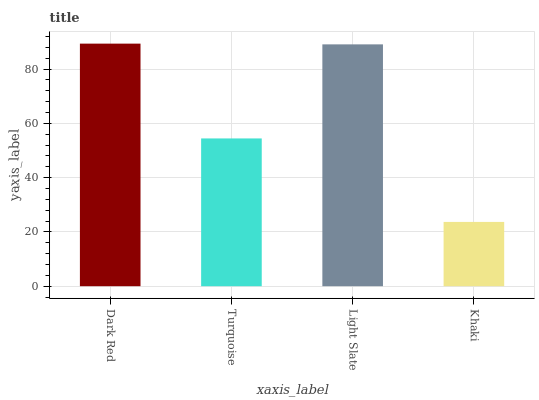Is Turquoise the minimum?
Answer yes or no. No. Is Turquoise the maximum?
Answer yes or no. No. Is Dark Red greater than Turquoise?
Answer yes or no. Yes. Is Turquoise less than Dark Red?
Answer yes or no. Yes. Is Turquoise greater than Dark Red?
Answer yes or no. No. Is Dark Red less than Turquoise?
Answer yes or no. No. Is Light Slate the high median?
Answer yes or no. Yes. Is Turquoise the low median?
Answer yes or no. Yes. Is Dark Red the high median?
Answer yes or no. No. Is Dark Red the low median?
Answer yes or no. No. 